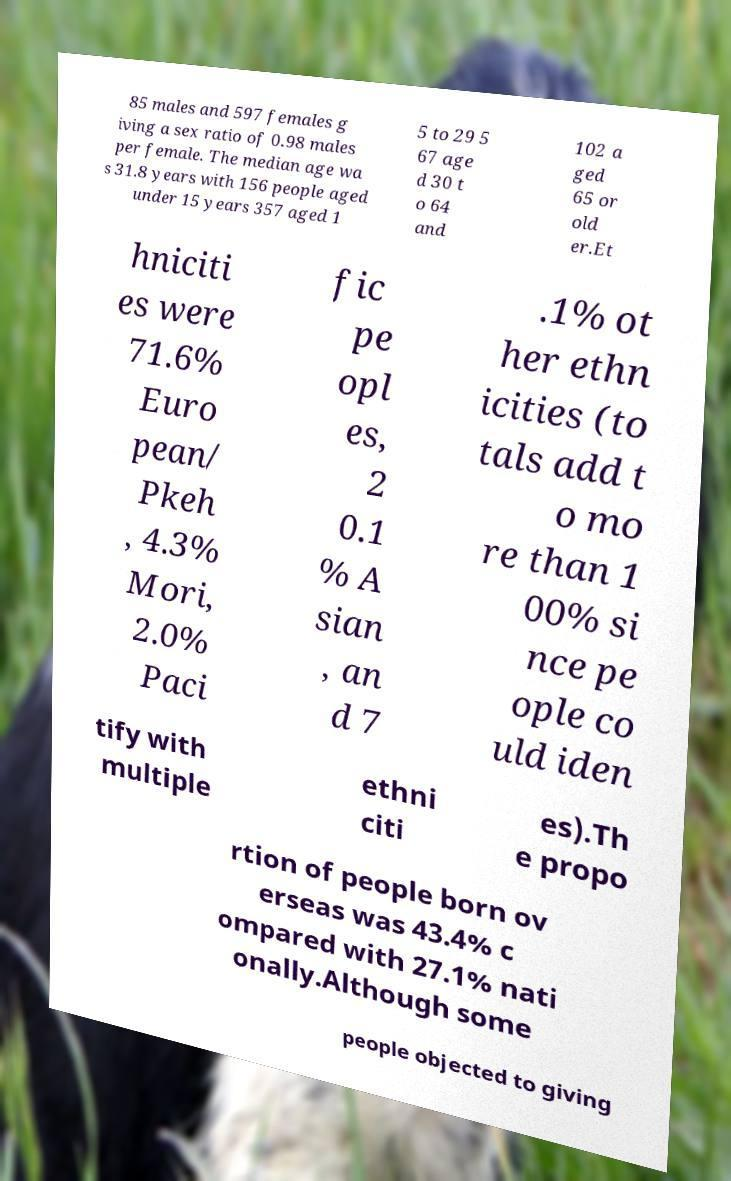There's text embedded in this image that I need extracted. Can you transcribe it verbatim? 85 males and 597 females g iving a sex ratio of 0.98 males per female. The median age wa s 31.8 years with 156 people aged under 15 years 357 aged 1 5 to 29 5 67 age d 30 t o 64 and 102 a ged 65 or old er.Et hniciti es were 71.6% Euro pean/ Pkeh , 4.3% Mori, 2.0% Paci fic pe opl es, 2 0.1 % A sian , an d 7 .1% ot her ethn icities (to tals add t o mo re than 1 00% si nce pe ople co uld iden tify with multiple ethni citi es).Th e propo rtion of people born ov erseas was 43.4% c ompared with 27.1% nati onally.Although some people objected to giving 